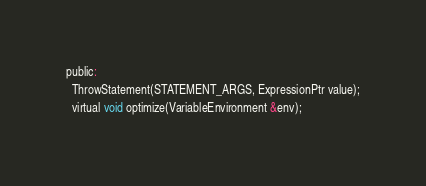Convert code to text. <code><loc_0><loc_0><loc_500><loc_500><_C_>public:
  ThrowStatement(STATEMENT_ARGS, ExpressionPtr value);
  virtual void optimize(VariableEnvironment &env);</code> 